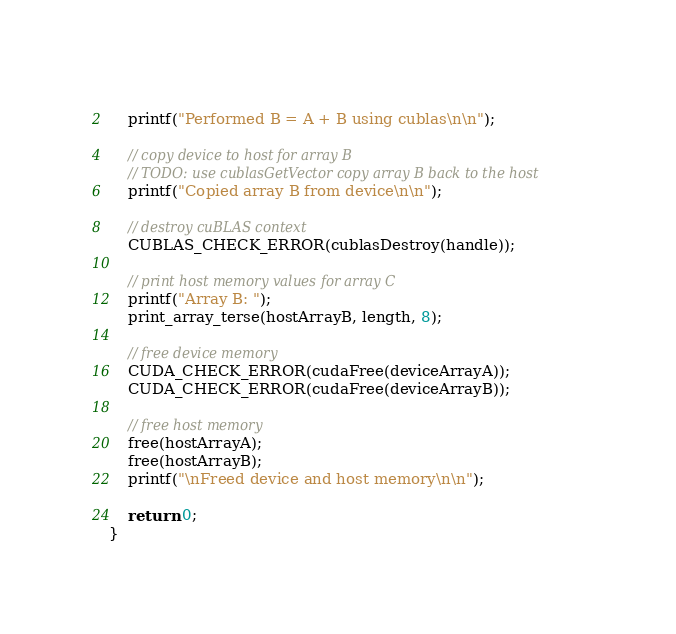<code> <loc_0><loc_0><loc_500><loc_500><_Cuda_>    
    printf("Performed B = A + B using cublas\n\n");

	// copy device to host for array B
	// TODO: use cublasGetVector copy array B back to the host
    printf("Copied array B from device\n\n");

    // destroy cuBLAS context
    CUBLAS_CHECK_ERROR(cublasDestroy(handle));

	// print host memory values for array C
    printf("Array B: ");
    print_array_terse(hostArrayB, length, 8);

	// free device memory
    CUDA_CHECK_ERROR(cudaFree(deviceArrayA));
    CUDA_CHECK_ERROR(cudaFree(deviceArrayB));
    
	// free host memory
	free(hostArrayA);
    free(hostArrayB);
    printf("\nFreed device and host memory\n\n");

	return 0;
}</code> 